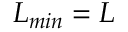<formula> <loc_0><loc_0><loc_500><loc_500>L _ { \min } = L</formula> 